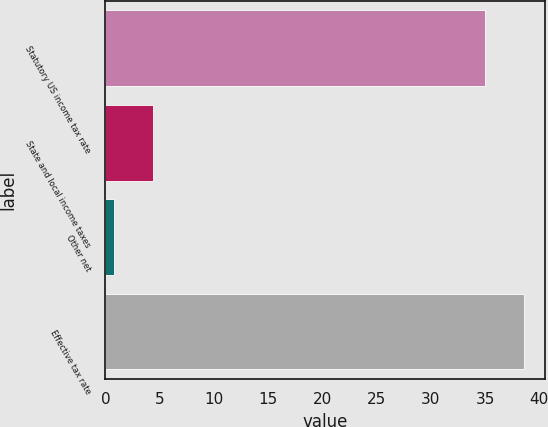Convert chart to OTSL. <chart><loc_0><loc_0><loc_500><loc_500><bar_chart><fcel>Statutory US income tax rate<fcel>State and local income taxes<fcel>Other net<fcel>Effective tax rate<nl><fcel>35<fcel>4.37<fcel>0.8<fcel>38.57<nl></chart> 